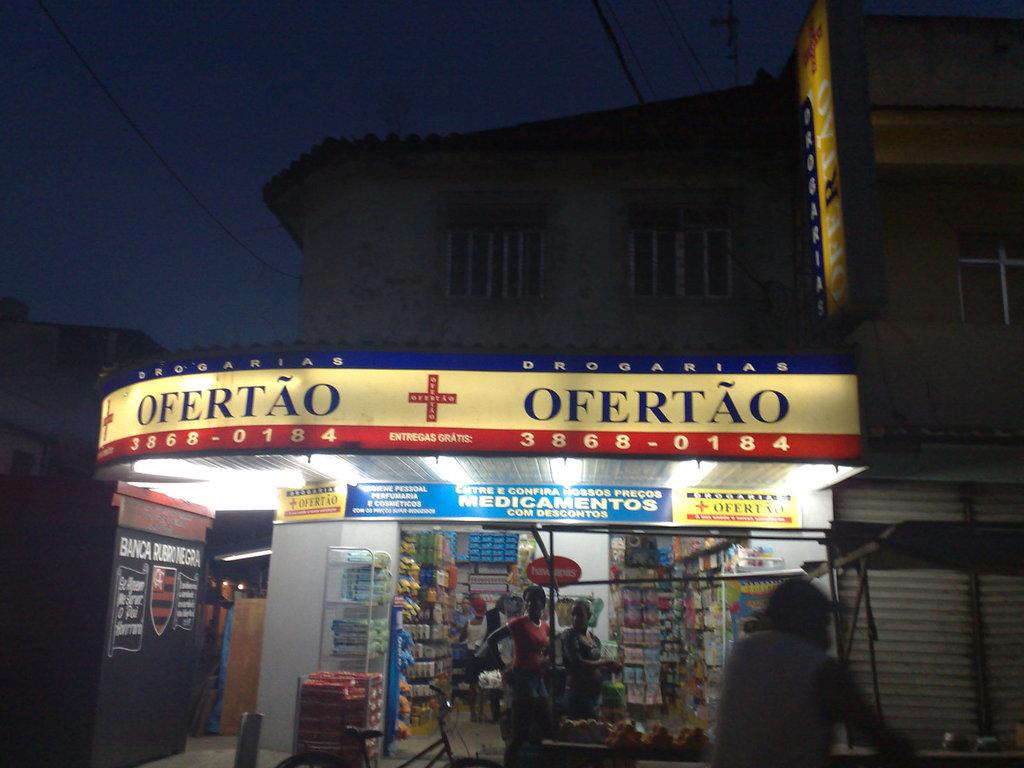What is the name of the store?
Provide a short and direct response. Ofertao. 